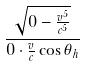Convert formula to latex. <formula><loc_0><loc_0><loc_500><loc_500>\frac { \sqrt { 0 - \frac { v ^ { 5 } } { c ^ { 5 } } } } { 0 \cdot \frac { v } { c } \cos \theta _ { h } }</formula> 